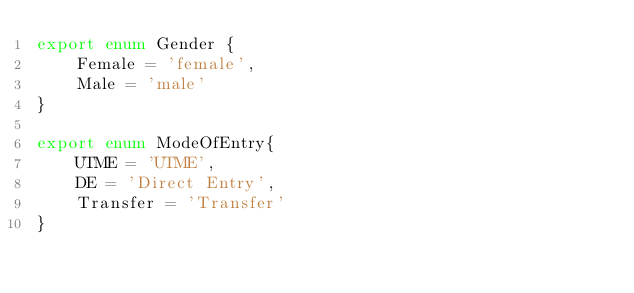<code> <loc_0><loc_0><loc_500><loc_500><_TypeScript_>export enum Gender {
    Female = 'female',
    Male = 'male'
}

export enum ModeOfEntry{
    UTME = 'UTME',
    DE = 'Direct Entry',
    Transfer = 'Transfer'
}</code> 